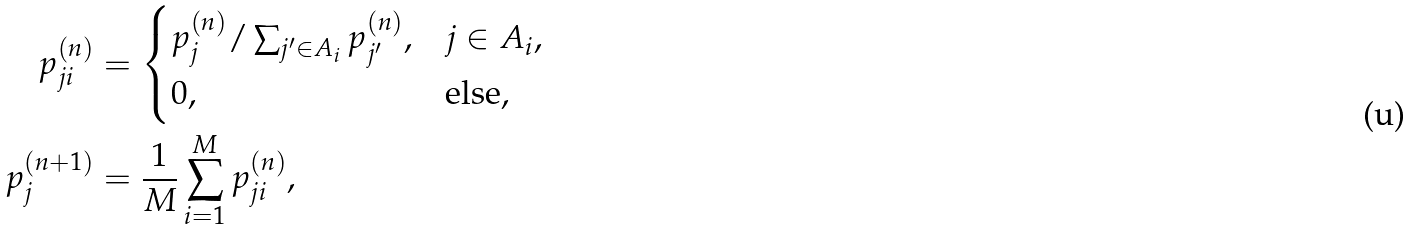Convert formula to latex. <formula><loc_0><loc_0><loc_500><loc_500>p _ { j i } ^ { ( n ) } & = \begin{cases} p _ { j } ^ { ( n ) } / \sum _ { j ^ { \prime } \in A _ { i } } p _ { j ^ { \prime } } ^ { ( n ) } , & j \in A _ { i } , \\ 0 , & \text {else} , \end{cases} \\ p _ { j } ^ { ( n + 1 ) } & = \frac { 1 } { M } \sum _ { i = 1 } ^ { M } p _ { j i } ^ { ( n ) } ,</formula> 